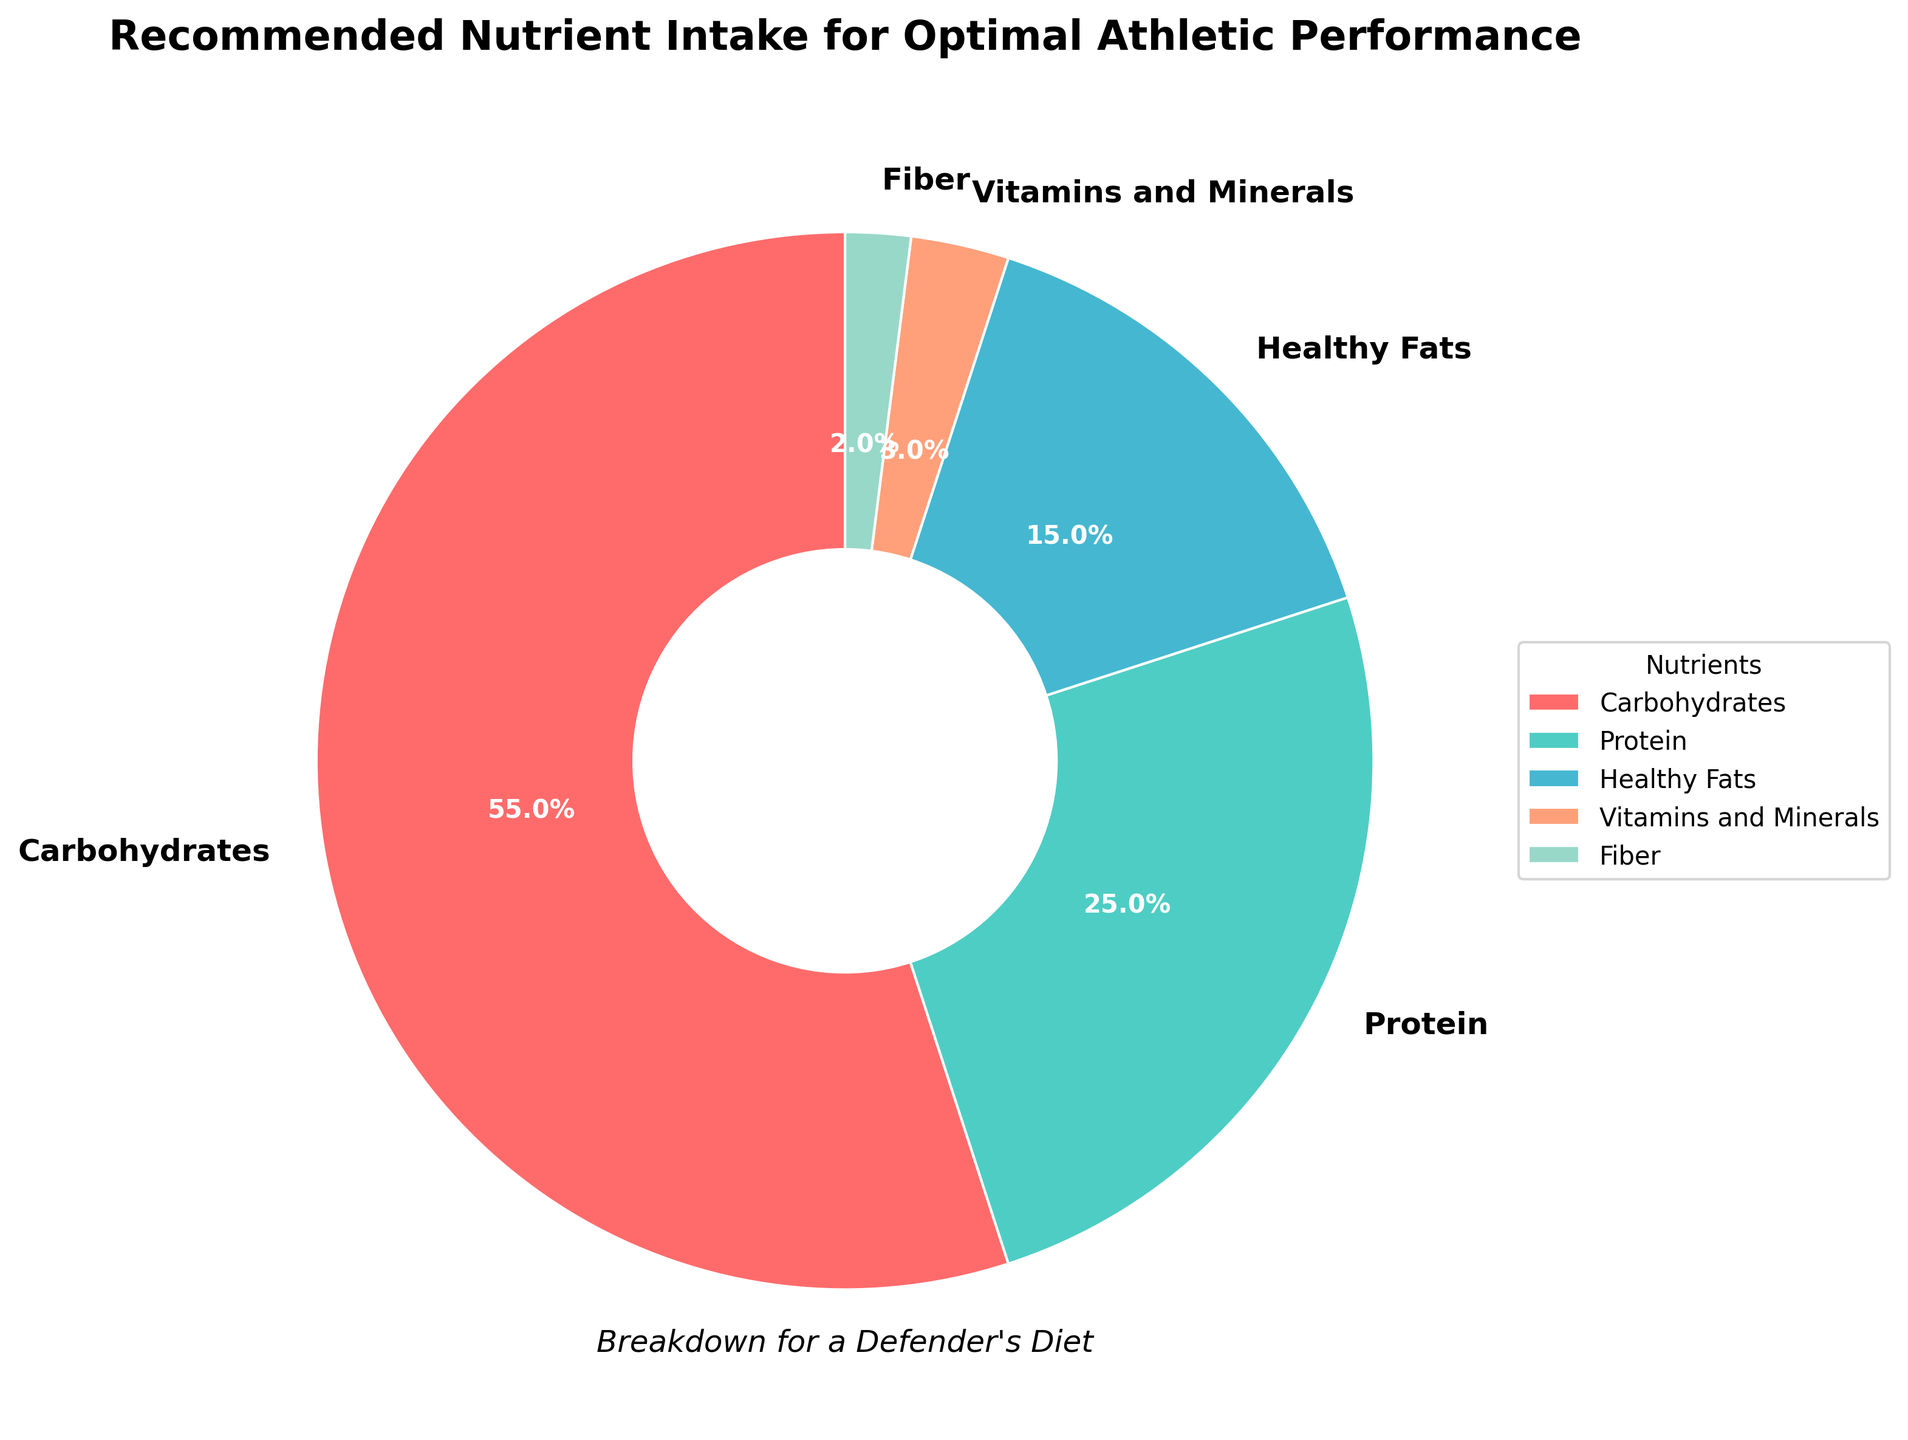What is the largest nutrient category in the pie chart? The largest nutrient category can be identified by looking at the segment that occupies the most space. In this case, the pie chart shows that "Carbohydrates" has the largest segment at 55%.
Answer: Carbohydrates Which nutrient has the smallest percentage in the pie chart? The smallest nutrient category can be identified by finding the segment that occupies the least amount of space. The chart indicates that "Fiber" is the smallest, with a 2% share.
Answer: Fiber How much more significant is the Carbohydrates segment compared to the Fiber segment? To determine the difference, subtract the percentage of Fiber from the percentage of Carbohydrates (55% - 2%). The difference is 53%.
Answer: 53% What is the combined percentage of Protein and Healthy Fats? To find the combined percentage, add the individual percentages of Protein (25%) and Healthy Fats (15%). The total is 25% + 15% = 40%.
Answer: 40% Compare the percentage of Vitamins and Minerals to Healthy Fats. Which one is greater and by how much? Vitamins and Minerals have a percentage of 3%, while Healthy Fats have 15%. Subtract 3% from 15% to find the difference: 15% - 3% = 12%.
Answer: Healthy Fats by 12% What color represents the Healthy Fats segment in the pie chart? The Healthy Fats segment is color-coded. Visually, we can see that Healthy Fats are displayed in orange.
Answer: Orange What is the sum of all the recommended nutrient percentages? The total is found by adding all the individual percentages: 55% (Carbohydrates) + 25% (Protein) + 15% (Healthy Fats) + 3% (Vitamins and Minerals) + 2% (Fiber) = 100%.
Answer: 100% Which two nutrients together account for the majority of the recommended intake? Adding the percentages together, we see that Carbohydrates (55%) and Protein (25%) make up 80% (55% + 25%), which is more than half.
Answer: Carbohydrates and Protein Is the percentage of Protein intake greater than the combined intake of Vitamins and Minerals and Fiber? Vitamin and Mineral intake is 3%, and Fiber intake is 2%. Their combined percentage is 3% + 2% = 5%. Protein alone has a percentage of 25%, which is greater than 5%.
Answer: Yes 